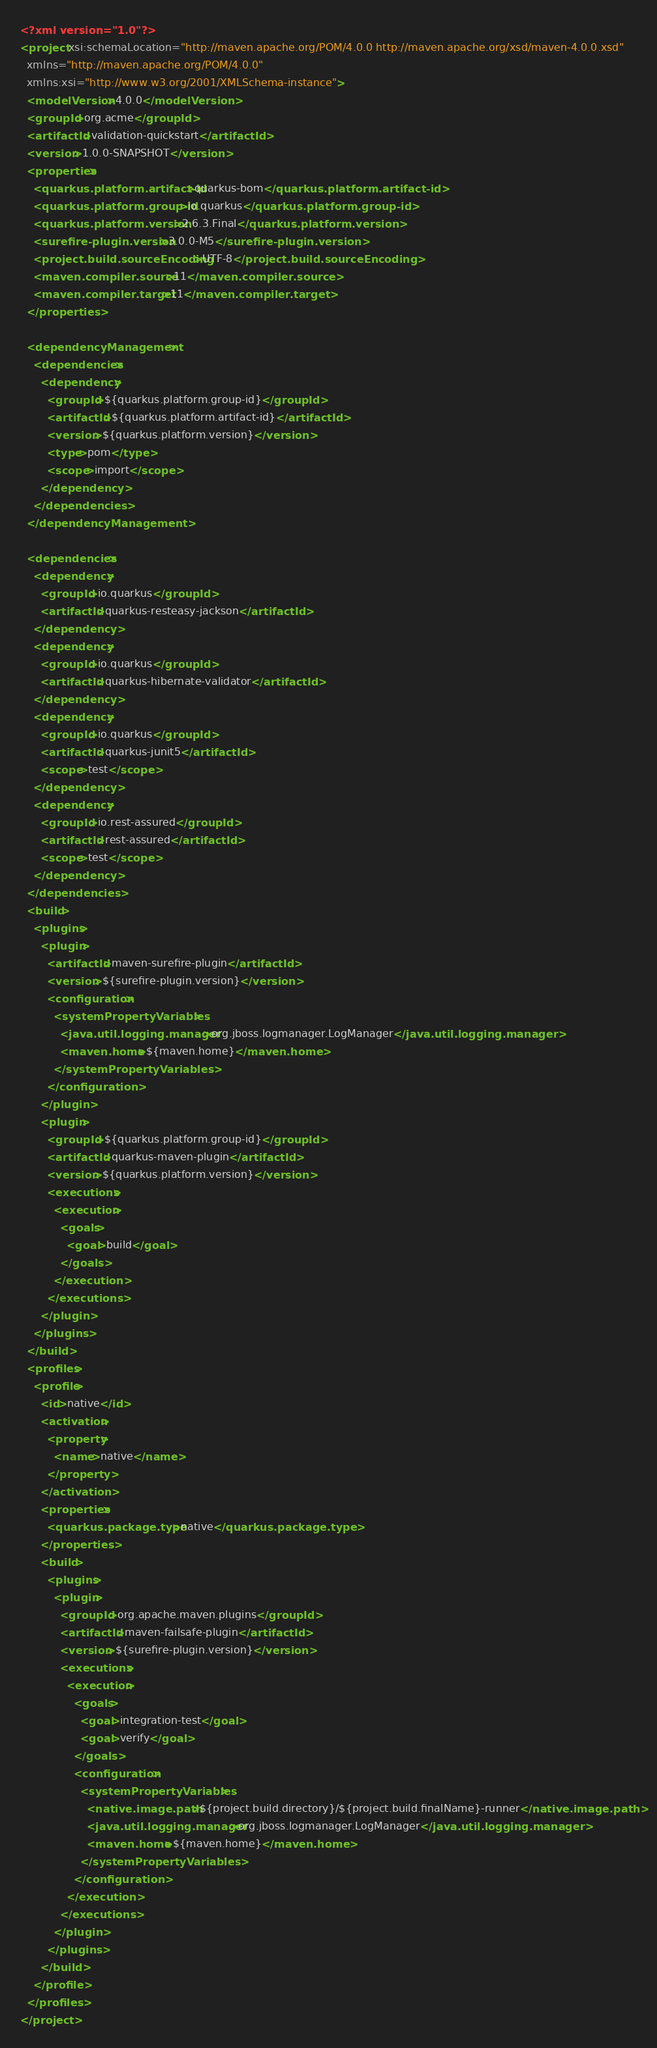<code> <loc_0><loc_0><loc_500><loc_500><_XML_><?xml version="1.0"?>
<project xsi:schemaLocation="http://maven.apache.org/POM/4.0.0 http://maven.apache.org/xsd/maven-4.0.0.xsd" 
  xmlns="http://maven.apache.org/POM/4.0.0" 
  xmlns:xsi="http://www.w3.org/2001/XMLSchema-instance">
  <modelVersion>4.0.0</modelVersion>
  <groupId>org.acme</groupId>
  <artifactId>validation-quickstart</artifactId>
  <version>1.0.0-SNAPSHOT</version>
  <properties>
    <quarkus.platform.artifact-id>quarkus-bom</quarkus.platform.artifact-id>
    <quarkus.platform.group-id>io.quarkus</quarkus.platform.group-id>
    <quarkus.platform.version>2.6.3.Final</quarkus.platform.version>
    <surefire-plugin.version>3.0.0-M5</surefire-plugin.version>
    <project.build.sourceEncoding>UTF-8</project.build.sourceEncoding>
    <maven.compiler.source>11</maven.compiler.source>
    <maven.compiler.target>11</maven.compiler.target>
  </properties>

  <dependencyManagement>
    <dependencies>
      <dependency>
        <groupId>${quarkus.platform.group-id}</groupId>
        <artifactId>${quarkus.platform.artifact-id}</artifactId>
        <version>${quarkus.platform.version}</version>
        <type>pom</type>
        <scope>import</scope>
      </dependency>
    </dependencies>
  </dependencyManagement>

  <dependencies>
    <dependency>
      <groupId>io.quarkus</groupId>
      <artifactId>quarkus-resteasy-jackson</artifactId>
    </dependency>
    <dependency>
      <groupId>io.quarkus</groupId>
      <artifactId>quarkus-hibernate-validator</artifactId>
    </dependency>
    <dependency>
      <groupId>io.quarkus</groupId>
      <artifactId>quarkus-junit5</artifactId>
      <scope>test</scope>
    </dependency>
    <dependency>
      <groupId>io.rest-assured</groupId>
      <artifactId>rest-assured</artifactId>
      <scope>test</scope>
    </dependency>
  </dependencies>
  <build>
    <plugins>
      <plugin>
        <artifactId>maven-surefire-plugin</artifactId>
        <version>${surefire-plugin.version}</version>
        <configuration>
          <systemPropertyVariables>
            <java.util.logging.manager>org.jboss.logmanager.LogManager</java.util.logging.manager>
            <maven.home>${maven.home}</maven.home>
          </systemPropertyVariables>
        </configuration>
      </plugin>
      <plugin>
        <groupId>${quarkus.platform.group-id}</groupId>
        <artifactId>quarkus-maven-plugin</artifactId>
        <version>${quarkus.platform.version}</version>
        <executions>
          <execution>
            <goals>
              <goal>build</goal>
            </goals>
          </execution>
        </executions>
      </plugin>
    </plugins>
  </build>
  <profiles>
    <profile>
      <id>native</id>
      <activation>
        <property>
          <name>native</name>
        </property>
      </activation>
      <properties>
        <quarkus.package.type>native</quarkus.package.type>
      </properties>
      <build>
        <plugins>
          <plugin>
            <groupId>org.apache.maven.plugins</groupId>
            <artifactId>maven-failsafe-plugin</artifactId>
            <version>${surefire-plugin.version}</version>
            <executions>
              <execution>
                <goals>
                  <goal>integration-test</goal>
                  <goal>verify</goal>
                </goals>
                <configuration>
                  <systemPropertyVariables>
                    <native.image.path>${project.build.directory}/${project.build.finalName}-runner</native.image.path>
                    <java.util.logging.manager>org.jboss.logmanager.LogManager</java.util.logging.manager>
                    <maven.home>${maven.home}</maven.home>
                  </systemPropertyVariables>                
                </configuration>
              </execution>
            </executions>
          </plugin>
        </plugins>
      </build>
    </profile>
  </profiles>
</project>
</code> 